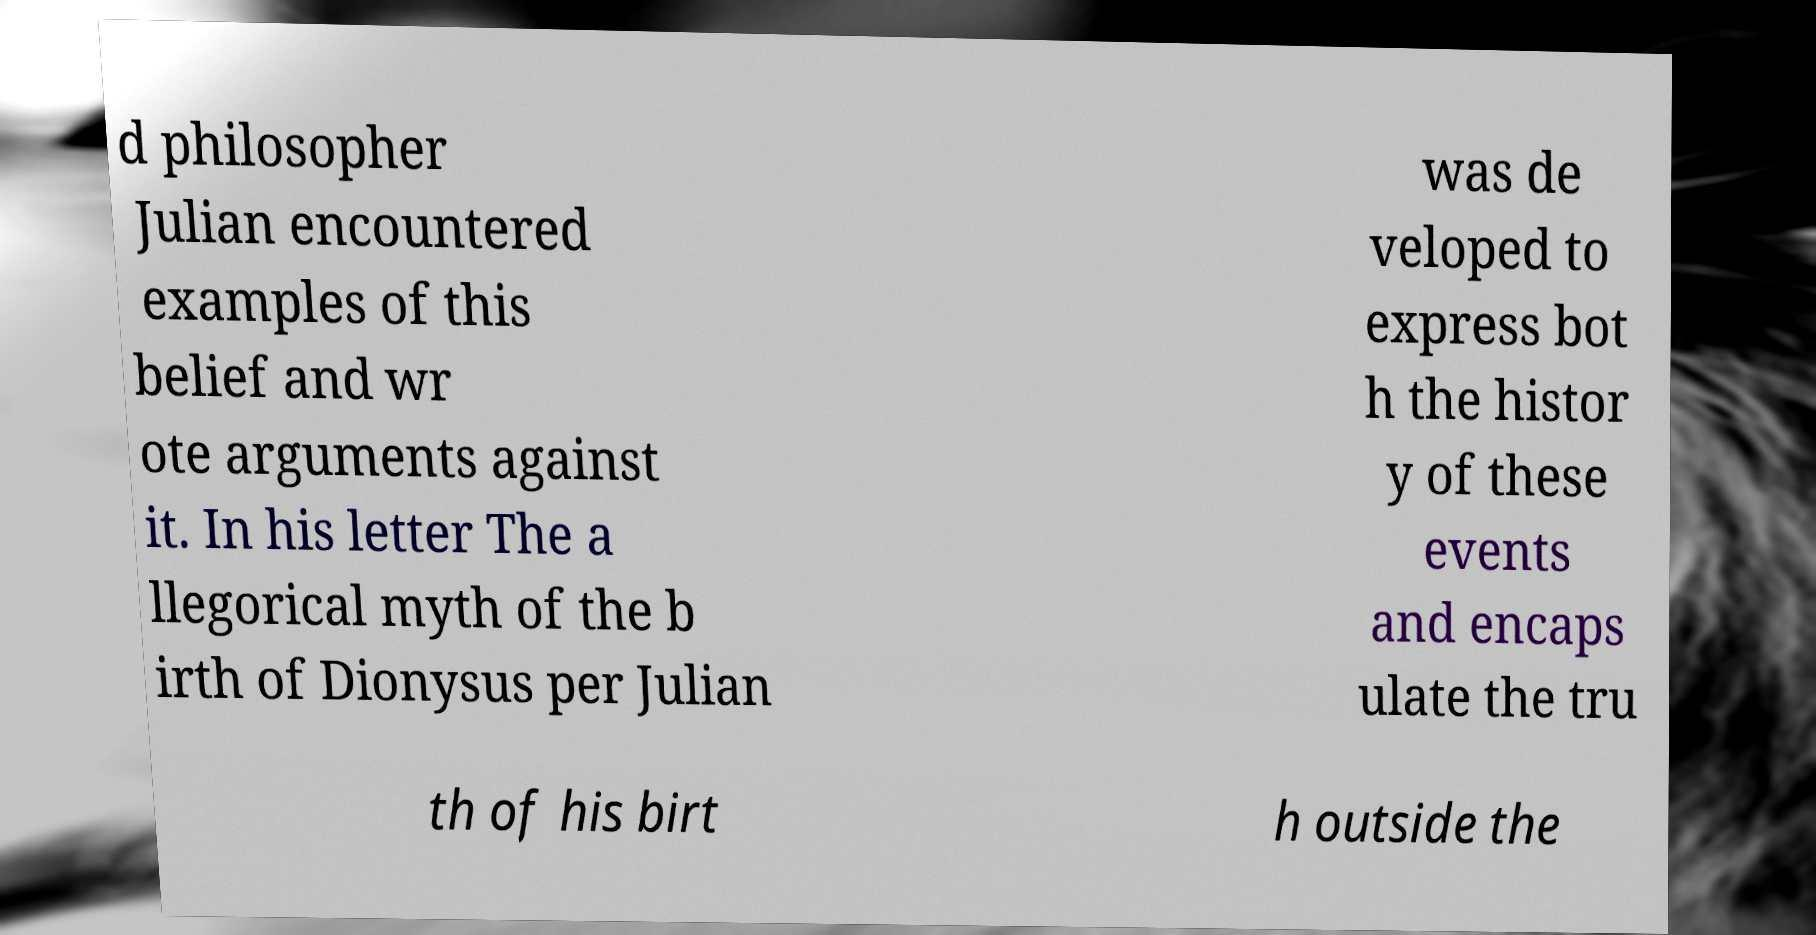There's text embedded in this image that I need extracted. Can you transcribe it verbatim? d philosopher Julian encountered examples of this belief and wr ote arguments against it. In his letter The a llegorical myth of the b irth of Dionysus per Julian was de veloped to express bot h the histor y of these events and encaps ulate the tru th of his birt h outside the 